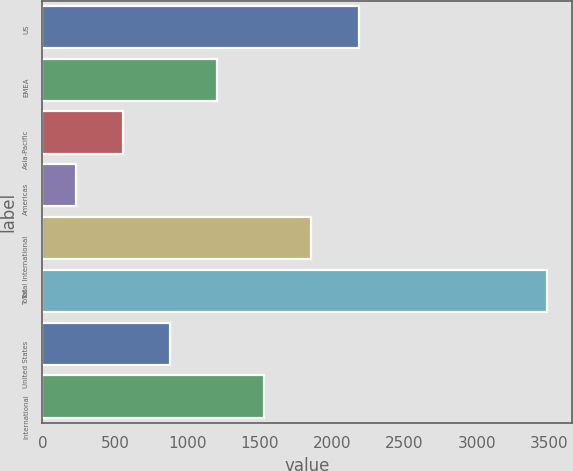Convert chart. <chart><loc_0><loc_0><loc_500><loc_500><bar_chart><fcel>US<fcel>EMEA<fcel>Asia-Pacific<fcel>Americas<fcel>Total International<fcel>Total<fcel>United States<fcel>International<nl><fcel>2182.3<fcel>1205.65<fcel>554.55<fcel>229<fcel>1856.75<fcel>3484.5<fcel>880.1<fcel>1531.2<nl></chart> 